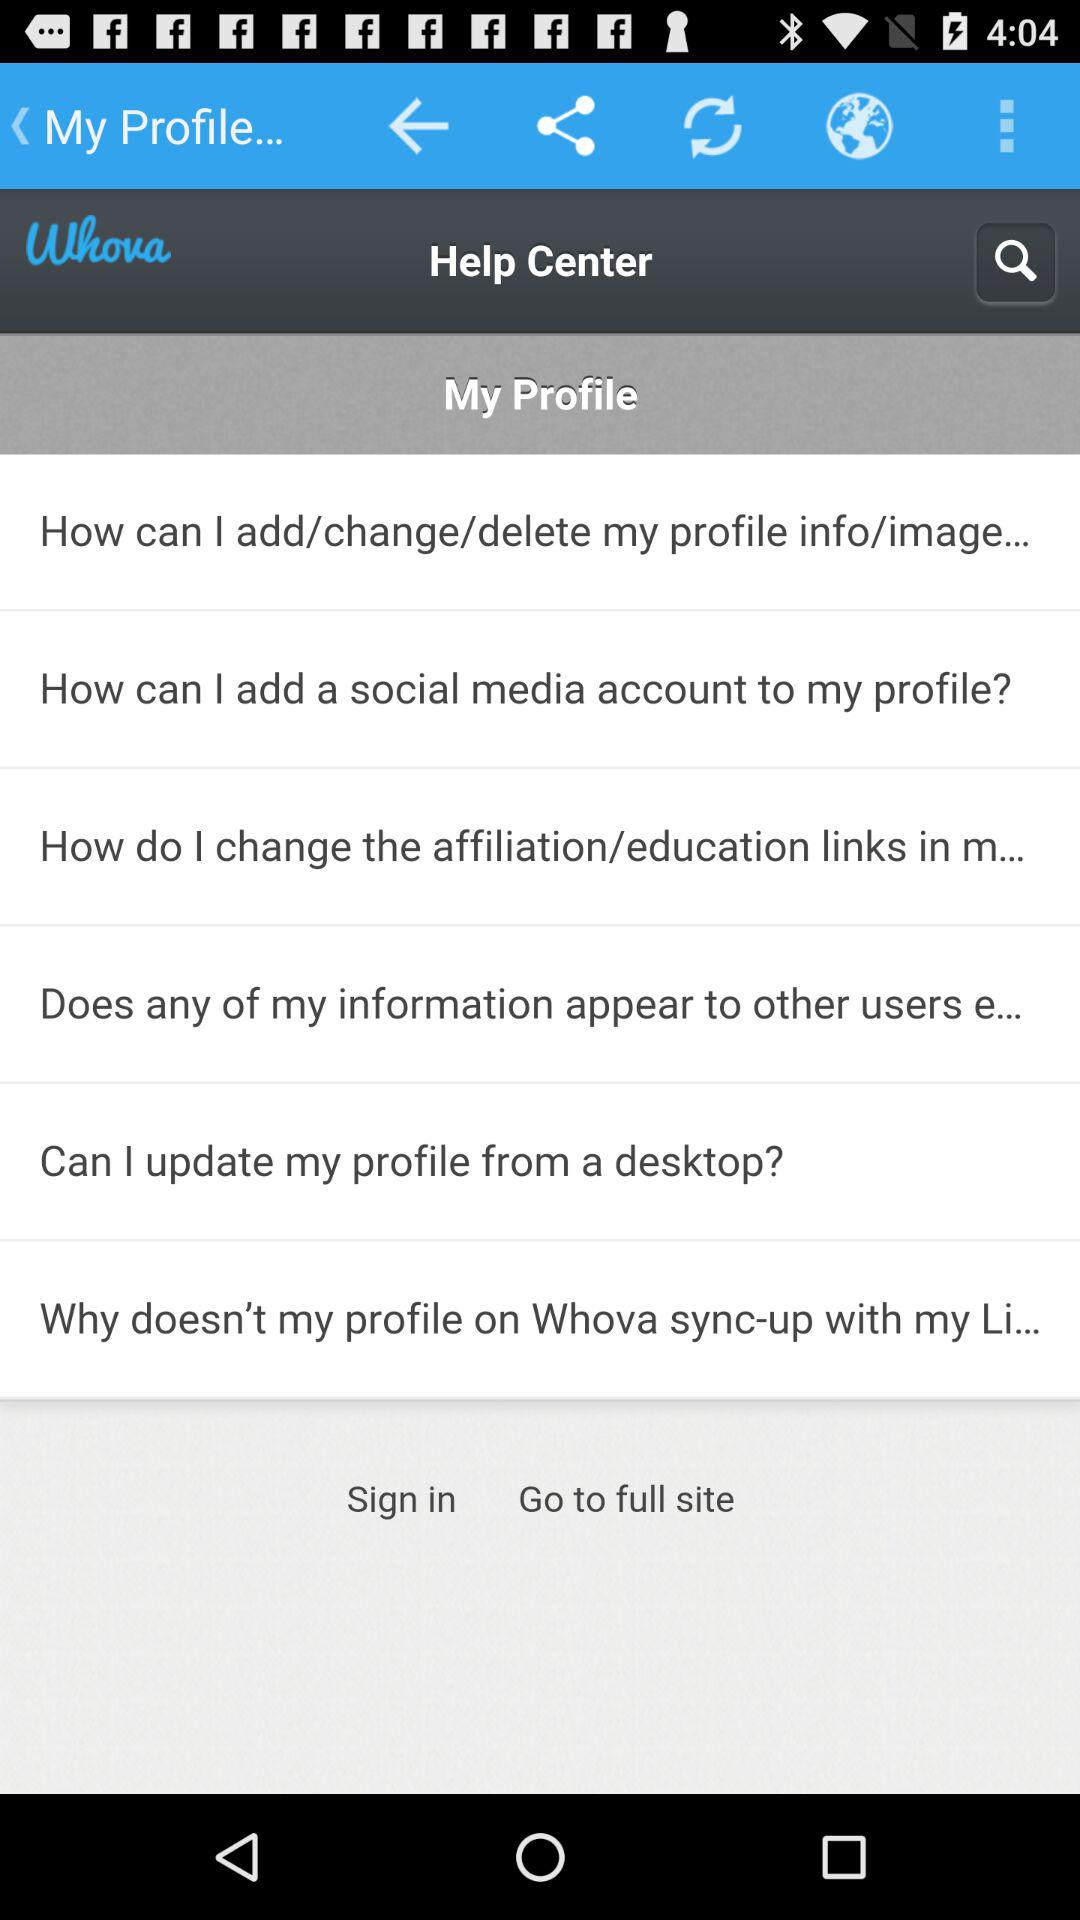What is the name of the application? The name of the application is "Whova". 